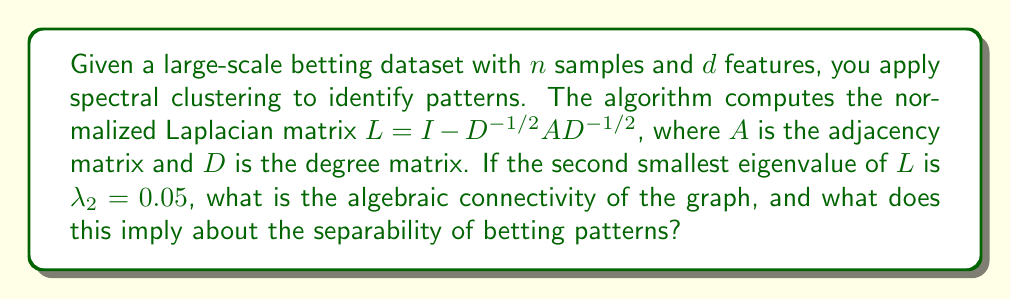What is the answer to this math problem? 1. The normalized Laplacian matrix $L$ is given by $L = I - D^{-1/2}AD^{-1/2}$.

2. The eigenvalues of $L$ are always in the range $[0, 2]$.

3. The second smallest eigenvalue of $L$, denoted as $\lambda_2$, is also known as the algebraic connectivity of the graph.

4. In this case, we are given that $\lambda_2 = 0.05$.

5. The algebraic connectivity is directly related to how well-connected the graph is:
   - If $\lambda_2 = 0$, the graph is disconnected.
   - Larger values of $\lambda_2$ indicate better connectivity.

6. A small value of $\lambda_2 = 0.05$ suggests that the graph is weakly connected.

7. In the context of betting patterns:
   - Weak connectivity implies that there are distinct clusters or communities in the betting data.
   - These clusters represent different betting patterns or strategies.
   - The low algebraic connectivity suggests that these patterns are relatively easy to separate or distinguish from one another.

8. This information can be valuable for identifying and analyzing different betting behaviors or strategies within the dataset.
Answer: $0.05$; implies easily separable betting patterns 